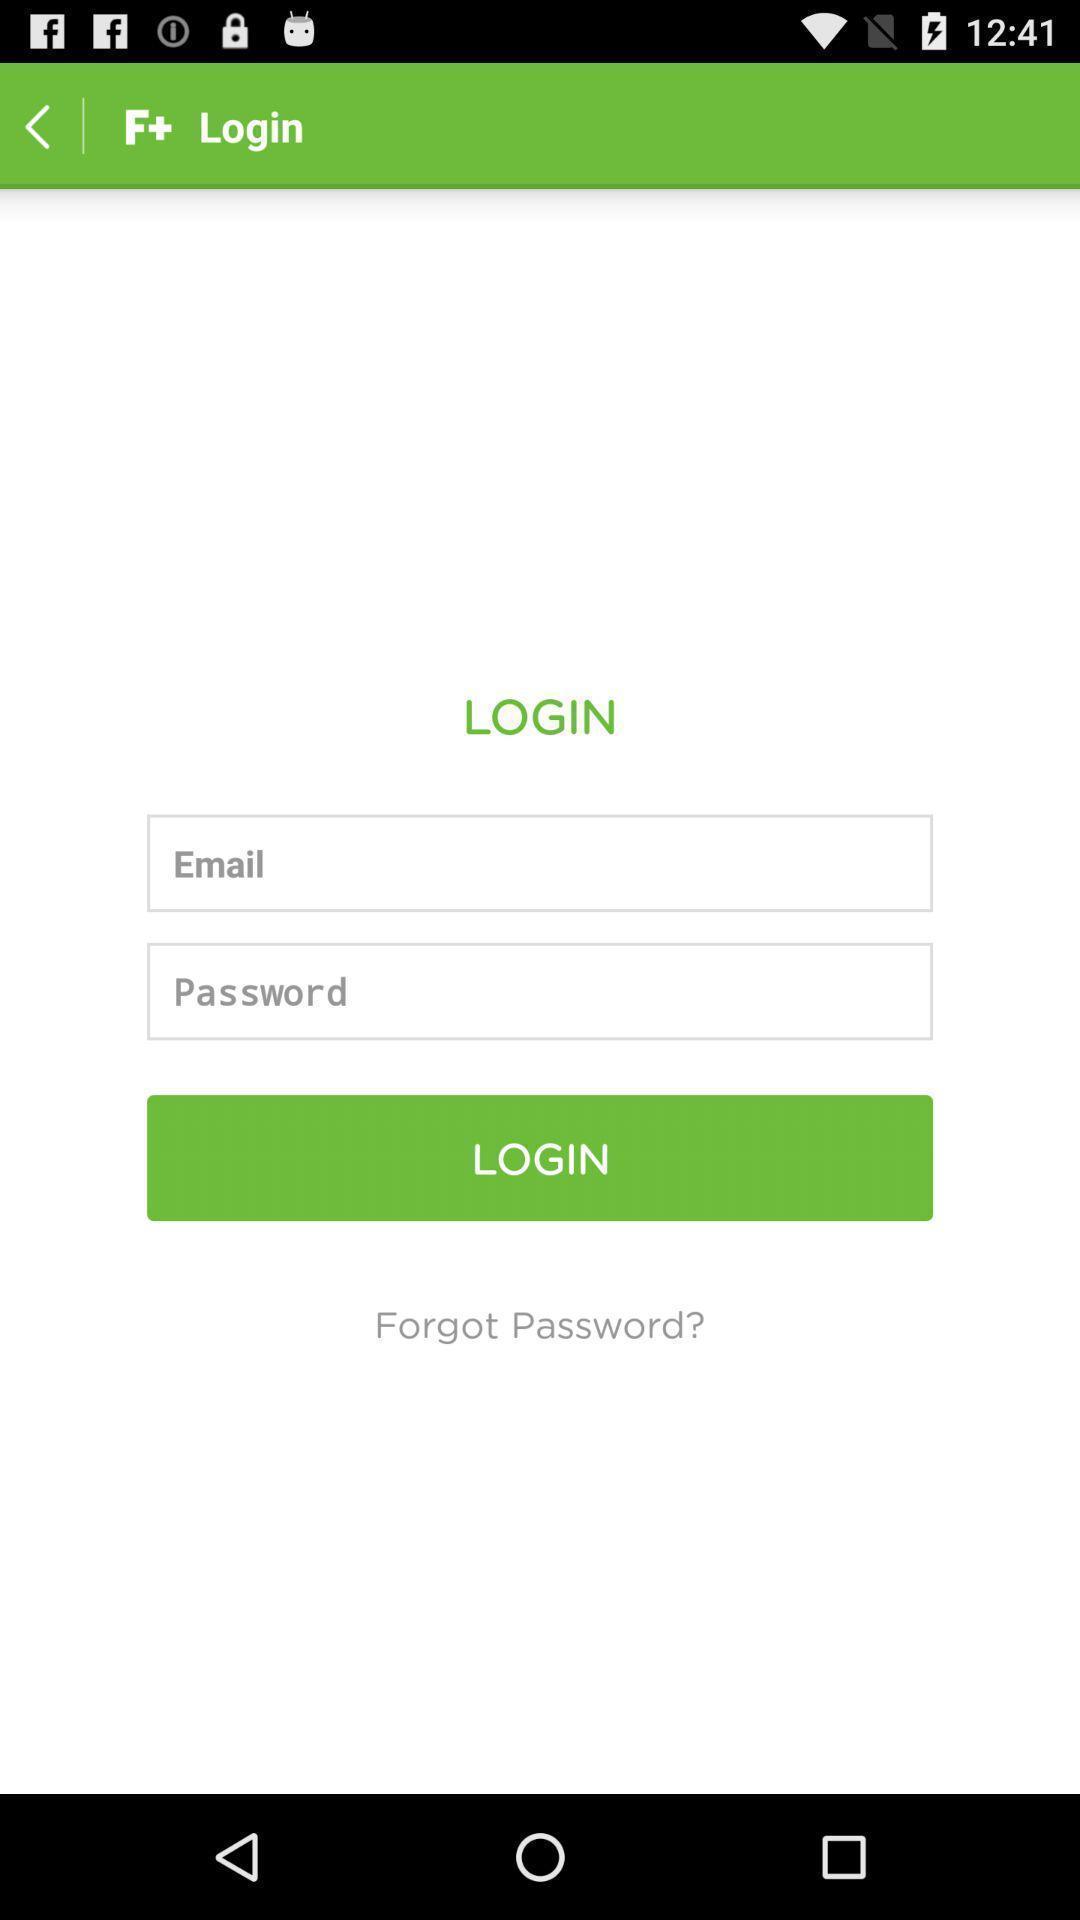What can you discern from this picture? Login page. 